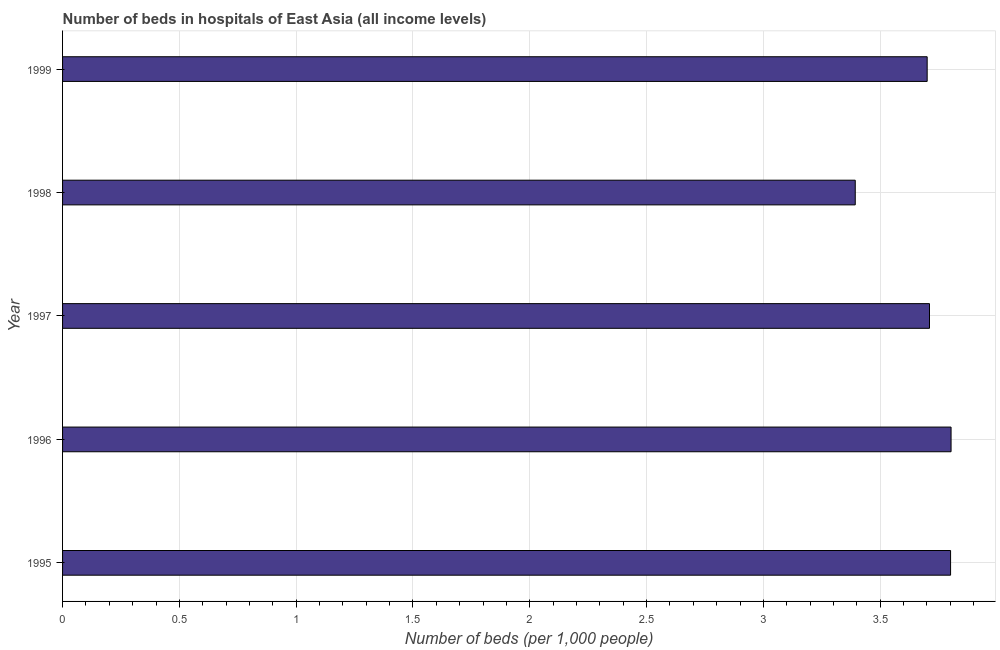Does the graph contain any zero values?
Keep it short and to the point. No. Does the graph contain grids?
Keep it short and to the point. Yes. What is the title of the graph?
Offer a terse response. Number of beds in hospitals of East Asia (all income levels). What is the label or title of the X-axis?
Keep it short and to the point. Number of beds (per 1,0 people). What is the label or title of the Y-axis?
Your response must be concise. Year. What is the number of hospital beds in 1995?
Ensure brevity in your answer.  3.8. Across all years, what is the maximum number of hospital beds?
Offer a terse response. 3.8. Across all years, what is the minimum number of hospital beds?
Provide a short and direct response. 3.39. In which year was the number of hospital beds maximum?
Make the answer very short. 1996. In which year was the number of hospital beds minimum?
Your response must be concise. 1998. What is the sum of the number of hospital beds?
Your answer should be compact. 18.41. What is the average number of hospital beds per year?
Your response must be concise. 3.68. What is the median number of hospital beds?
Offer a very short reply. 3.71. Do a majority of the years between 1999 and 1995 (inclusive) have number of hospital beds greater than 0.3 %?
Your answer should be compact. Yes. What is the ratio of the number of hospital beds in 1995 to that in 1997?
Your answer should be very brief. 1.02. What is the difference between the highest and the second highest number of hospital beds?
Your response must be concise. 0. Is the sum of the number of hospital beds in 1995 and 1997 greater than the maximum number of hospital beds across all years?
Keep it short and to the point. Yes. What is the difference between the highest and the lowest number of hospital beds?
Ensure brevity in your answer.  0.41. What is the difference between two consecutive major ticks on the X-axis?
Give a very brief answer. 0.5. Are the values on the major ticks of X-axis written in scientific E-notation?
Your answer should be compact. No. What is the Number of beds (per 1,000 people) in 1995?
Offer a terse response. 3.8. What is the Number of beds (per 1,000 people) in 1996?
Provide a succinct answer. 3.8. What is the Number of beds (per 1,000 people) of 1997?
Provide a short and direct response. 3.71. What is the Number of beds (per 1,000 people) in 1998?
Provide a short and direct response. 3.39. What is the Number of beds (per 1,000 people) in 1999?
Offer a terse response. 3.7. What is the difference between the Number of beds (per 1,000 people) in 1995 and 1996?
Your response must be concise. -0. What is the difference between the Number of beds (per 1,000 people) in 1995 and 1997?
Provide a succinct answer. 0.09. What is the difference between the Number of beds (per 1,000 people) in 1995 and 1998?
Give a very brief answer. 0.41. What is the difference between the Number of beds (per 1,000 people) in 1995 and 1999?
Keep it short and to the point. 0.1. What is the difference between the Number of beds (per 1,000 people) in 1996 and 1997?
Make the answer very short. 0.09. What is the difference between the Number of beds (per 1,000 people) in 1996 and 1998?
Your answer should be compact. 0.41. What is the difference between the Number of beds (per 1,000 people) in 1996 and 1999?
Give a very brief answer. 0.1. What is the difference between the Number of beds (per 1,000 people) in 1997 and 1998?
Provide a succinct answer. 0.32. What is the difference between the Number of beds (per 1,000 people) in 1997 and 1999?
Offer a terse response. 0.01. What is the difference between the Number of beds (per 1,000 people) in 1998 and 1999?
Provide a short and direct response. -0.31. What is the ratio of the Number of beds (per 1,000 people) in 1995 to that in 1996?
Provide a succinct answer. 1. What is the ratio of the Number of beds (per 1,000 people) in 1995 to that in 1998?
Ensure brevity in your answer.  1.12. What is the ratio of the Number of beds (per 1,000 people) in 1996 to that in 1998?
Your answer should be very brief. 1.12. What is the ratio of the Number of beds (per 1,000 people) in 1996 to that in 1999?
Your answer should be compact. 1.03. What is the ratio of the Number of beds (per 1,000 people) in 1997 to that in 1998?
Keep it short and to the point. 1.09. What is the ratio of the Number of beds (per 1,000 people) in 1997 to that in 1999?
Your answer should be very brief. 1. What is the ratio of the Number of beds (per 1,000 people) in 1998 to that in 1999?
Offer a terse response. 0.92. 